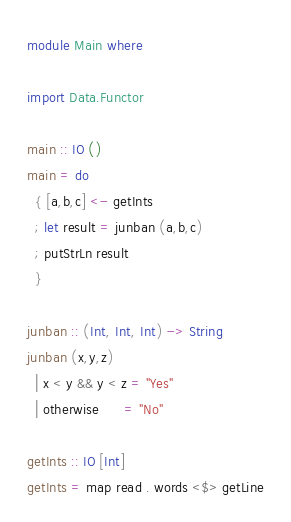Convert code to text. <code><loc_0><loc_0><loc_500><loc_500><_Haskell_>module Main where

import Data.Functor

main :: IO ()
main = do
  { [a,b,c] <- getInts
  ; let result = junban (a,b,c)
  ; putStrLn result
  }

junban :: (Int, Int, Int) -> String
junban (x,y,z)
  | x < y && y < z = "Yes"
  | otherwise      = "No"

getInts :: IO [Int]
getInts = map read . words <$> getLine</code> 